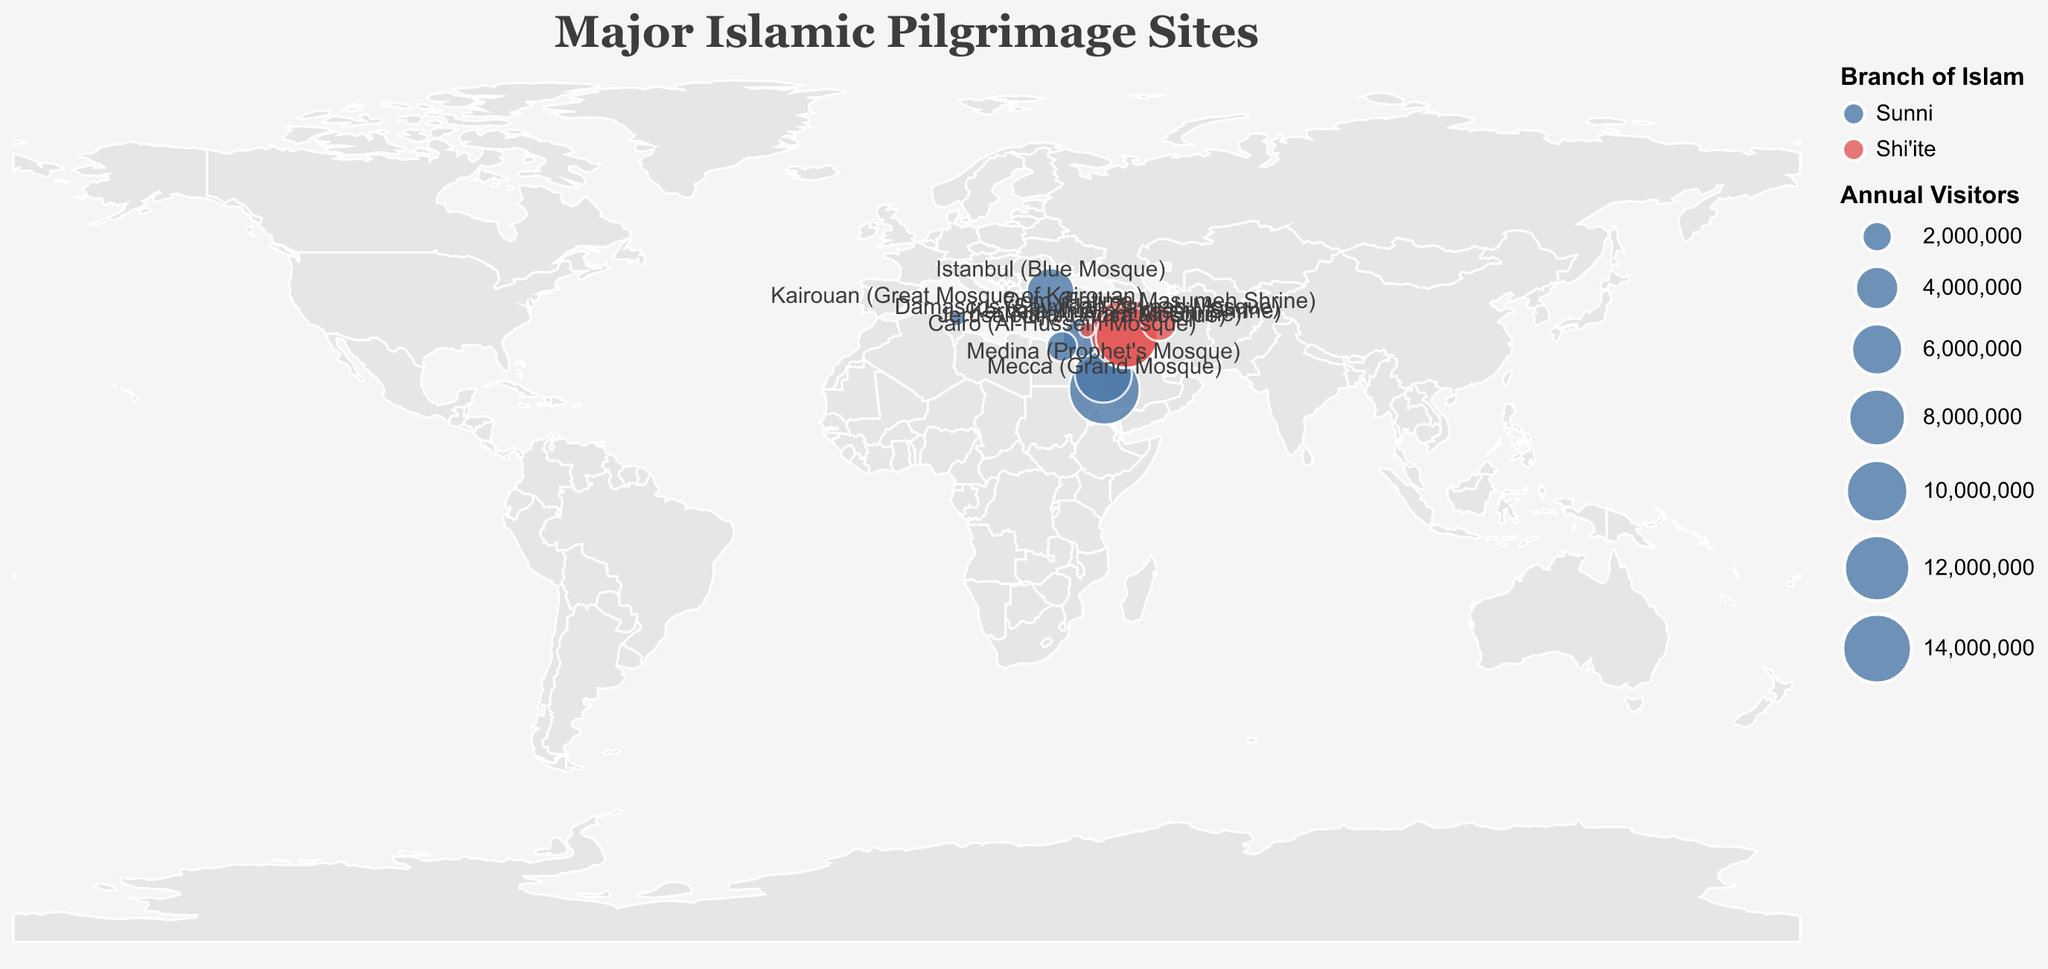How many Sunni pilgrimage sites are shown on the map? There are ten pilgrimage sites in total. By counting only the "Sunni" in the "Type" field from the tooltip, we see there are six Sunni pilgrimage sites.
Answer: 6 Which pilgrimage site has the highest number of annual visitors? By comparing the "Annual Visitors" field across all tooltip entries, the Grand Mosque in Mecca has the most visitors with 15,000,000.
Answer: Mecca (Grand Mosque) What's the total number of annual visitors for all Sunni pilgrimage sites combined? Summing the annual visitors for Sunni sites: Mecca (15,000,000), Medina (8,000,000), Jerusalem (3,000,000), Cairo (2,000,000), Kairouan (1,000,000), and Istanbul (5,000,000), the total is 34,000,000.
Answer: 34,000,000 Are there more Sunni or Shi'ite pilgrimage sites shown on the map? By counting the instances of "Sunni" and "Shi'ite" from the tooltip entries, there are more Sunni sites (6) than Shi'ite sites (4).
Answer: Sunni Which Shi'ite pilgrimage site has the lowest number of annual visitors? By comparing the "Annual Visitors" field for Shi'ite sites, the Sayyidah Zaynab Mosque in Damascus has 1,000,000 visitors, which is the lowest among Shi'ite sites.
Answer: Sayyidah Zaynab Mosque What is the latitude of the Prophet's Mosque in Medina? By observing the tooltip for Medina (Prophet's Mosque), the latitude is listed directly as 24.4672.
Answer: 24.4672 Which pilgrimage site is closest to the coordinates (32, 44)? By comparing the given coordinates to the latitude and longitude values in the tooltip, the Imam Hussain Shrine in Karbala (32.6167, 44.0333) is closest.
Answer: Imam Hussain Shrine How many pilgrimage sites have over 5,000,000 annual visitors? Counting all sites with more than 5,000,000 annual visitors from the tooltip entries, there are four: Mecca (15,000,000), Karbala (14,000,000), Medina (8,000,000), and Istanbul (5,000,000).
Answer: 4 Which site is further north: the Great Mosque of Kairouan or the Blue Mosque in Istanbul? By comparing the latitudes from the tooltip entries, Istanbul (41.0054) is further north than Kairouan (35.6804).
Answer: Blue Mosque in Istanbul 